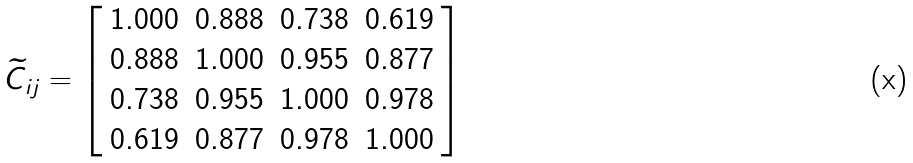Convert formula to latex. <formula><loc_0><loc_0><loc_500><loc_500>\widetilde { C } _ { i j } = \left [ \begin{array} { c c c c } 1 . 0 0 0 & 0 . 8 8 8 & 0 . 7 3 8 & 0 . 6 1 9 \\ 0 . 8 8 8 & 1 . 0 0 0 & 0 . 9 5 5 & 0 . 8 7 7 \\ 0 . 7 3 8 & 0 . 9 5 5 & 1 . 0 0 0 & 0 . 9 7 8 \\ 0 . 6 1 9 & 0 . 8 7 7 & 0 . 9 7 8 & 1 . 0 0 0 \end{array} \right ]</formula> 